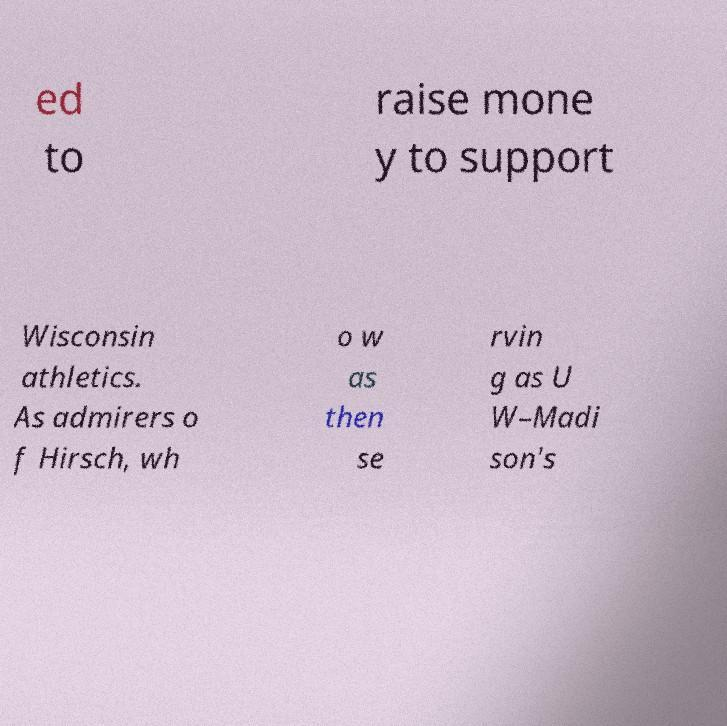Please read and relay the text visible in this image. What does it say? ed to raise mone y to support Wisconsin athletics. As admirers o f Hirsch, wh o w as then se rvin g as U W–Madi son's 